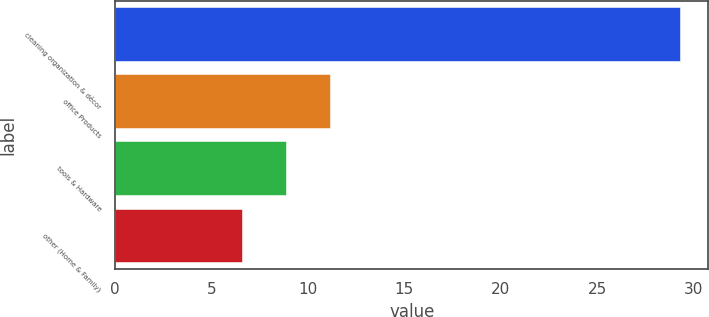<chart> <loc_0><loc_0><loc_500><loc_500><bar_chart><fcel>cleaning organization & décor<fcel>office Products<fcel>tools & Hardware<fcel>other (Home & Family)<nl><fcel>29.3<fcel>11.14<fcel>8.87<fcel>6.6<nl></chart> 